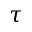Convert formula to latex. <formula><loc_0><loc_0><loc_500><loc_500>\tau</formula> 